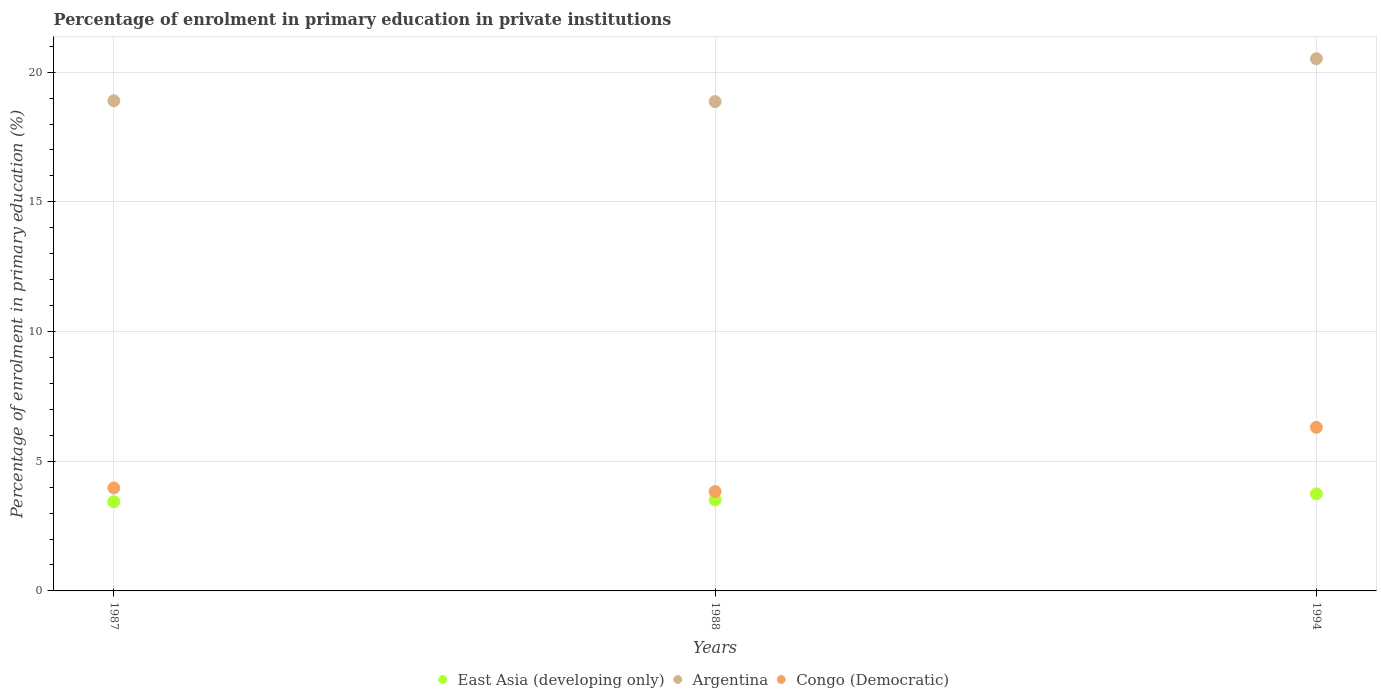How many different coloured dotlines are there?
Give a very brief answer. 3. What is the percentage of enrolment in primary education in Congo (Democratic) in 1988?
Make the answer very short. 3.83. Across all years, what is the maximum percentage of enrolment in primary education in Argentina?
Keep it short and to the point. 20.52. Across all years, what is the minimum percentage of enrolment in primary education in Congo (Democratic)?
Keep it short and to the point. 3.83. What is the total percentage of enrolment in primary education in Argentina in the graph?
Keep it short and to the point. 58.28. What is the difference between the percentage of enrolment in primary education in East Asia (developing only) in 1987 and that in 1988?
Provide a succinct answer. -0.07. What is the difference between the percentage of enrolment in primary education in Argentina in 1988 and the percentage of enrolment in primary education in Congo (Democratic) in 1987?
Your answer should be very brief. 14.89. What is the average percentage of enrolment in primary education in East Asia (developing only) per year?
Make the answer very short. 3.56. In the year 1994, what is the difference between the percentage of enrolment in primary education in Argentina and percentage of enrolment in primary education in East Asia (developing only)?
Offer a terse response. 16.77. What is the ratio of the percentage of enrolment in primary education in Argentina in 1987 to that in 1994?
Ensure brevity in your answer.  0.92. Is the percentage of enrolment in primary education in Argentina in 1988 less than that in 1994?
Your response must be concise. Yes. Is the difference between the percentage of enrolment in primary education in Argentina in 1988 and 1994 greater than the difference between the percentage of enrolment in primary education in East Asia (developing only) in 1988 and 1994?
Provide a short and direct response. No. What is the difference between the highest and the second highest percentage of enrolment in primary education in East Asia (developing only)?
Provide a succinct answer. 0.23. What is the difference between the highest and the lowest percentage of enrolment in primary education in East Asia (developing only)?
Offer a very short reply. 0.3. In how many years, is the percentage of enrolment in primary education in East Asia (developing only) greater than the average percentage of enrolment in primary education in East Asia (developing only) taken over all years?
Make the answer very short. 1. Is the sum of the percentage of enrolment in primary education in East Asia (developing only) in 1987 and 1994 greater than the maximum percentage of enrolment in primary education in Argentina across all years?
Your response must be concise. No. Is the percentage of enrolment in primary education in East Asia (developing only) strictly greater than the percentage of enrolment in primary education in Argentina over the years?
Offer a very short reply. No. Is the percentage of enrolment in primary education in Congo (Democratic) strictly less than the percentage of enrolment in primary education in East Asia (developing only) over the years?
Make the answer very short. No. Does the graph contain any zero values?
Provide a short and direct response. No. Does the graph contain grids?
Your answer should be very brief. Yes. Where does the legend appear in the graph?
Give a very brief answer. Bottom center. How are the legend labels stacked?
Give a very brief answer. Horizontal. What is the title of the graph?
Offer a very short reply. Percentage of enrolment in primary education in private institutions. Does "Latvia" appear as one of the legend labels in the graph?
Your response must be concise. No. What is the label or title of the Y-axis?
Provide a short and direct response. Percentage of enrolment in primary education (%). What is the Percentage of enrolment in primary education (%) in East Asia (developing only) in 1987?
Provide a succinct answer. 3.44. What is the Percentage of enrolment in primary education (%) in Argentina in 1987?
Your answer should be very brief. 18.9. What is the Percentage of enrolment in primary education (%) of Congo (Democratic) in 1987?
Provide a short and direct response. 3.97. What is the Percentage of enrolment in primary education (%) of East Asia (developing only) in 1988?
Provide a short and direct response. 3.51. What is the Percentage of enrolment in primary education (%) of Argentina in 1988?
Keep it short and to the point. 18.86. What is the Percentage of enrolment in primary education (%) of Congo (Democratic) in 1988?
Keep it short and to the point. 3.83. What is the Percentage of enrolment in primary education (%) in East Asia (developing only) in 1994?
Give a very brief answer. 3.74. What is the Percentage of enrolment in primary education (%) of Argentina in 1994?
Ensure brevity in your answer.  20.52. What is the Percentage of enrolment in primary education (%) of Congo (Democratic) in 1994?
Your answer should be compact. 6.31. Across all years, what is the maximum Percentage of enrolment in primary education (%) in East Asia (developing only)?
Provide a short and direct response. 3.74. Across all years, what is the maximum Percentage of enrolment in primary education (%) of Argentina?
Give a very brief answer. 20.52. Across all years, what is the maximum Percentage of enrolment in primary education (%) in Congo (Democratic)?
Your answer should be compact. 6.31. Across all years, what is the minimum Percentage of enrolment in primary education (%) of East Asia (developing only)?
Your response must be concise. 3.44. Across all years, what is the minimum Percentage of enrolment in primary education (%) of Argentina?
Offer a very short reply. 18.86. Across all years, what is the minimum Percentage of enrolment in primary education (%) of Congo (Democratic)?
Offer a terse response. 3.83. What is the total Percentage of enrolment in primary education (%) in East Asia (developing only) in the graph?
Your answer should be very brief. 10.69. What is the total Percentage of enrolment in primary education (%) of Argentina in the graph?
Keep it short and to the point. 58.28. What is the total Percentage of enrolment in primary education (%) of Congo (Democratic) in the graph?
Provide a short and direct response. 14.11. What is the difference between the Percentage of enrolment in primary education (%) of East Asia (developing only) in 1987 and that in 1988?
Provide a short and direct response. -0.07. What is the difference between the Percentage of enrolment in primary education (%) in Argentina in 1987 and that in 1988?
Make the answer very short. 0.03. What is the difference between the Percentage of enrolment in primary education (%) of Congo (Democratic) in 1987 and that in 1988?
Give a very brief answer. 0.14. What is the difference between the Percentage of enrolment in primary education (%) of East Asia (developing only) in 1987 and that in 1994?
Keep it short and to the point. -0.3. What is the difference between the Percentage of enrolment in primary education (%) in Argentina in 1987 and that in 1994?
Make the answer very short. -1.62. What is the difference between the Percentage of enrolment in primary education (%) of Congo (Democratic) in 1987 and that in 1994?
Your answer should be very brief. -2.34. What is the difference between the Percentage of enrolment in primary education (%) of East Asia (developing only) in 1988 and that in 1994?
Offer a terse response. -0.23. What is the difference between the Percentage of enrolment in primary education (%) in Argentina in 1988 and that in 1994?
Make the answer very short. -1.65. What is the difference between the Percentage of enrolment in primary education (%) in Congo (Democratic) in 1988 and that in 1994?
Offer a very short reply. -2.47. What is the difference between the Percentage of enrolment in primary education (%) of East Asia (developing only) in 1987 and the Percentage of enrolment in primary education (%) of Argentina in 1988?
Keep it short and to the point. -15.42. What is the difference between the Percentage of enrolment in primary education (%) of East Asia (developing only) in 1987 and the Percentage of enrolment in primary education (%) of Congo (Democratic) in 1988?
Your response must be concise. -0.39. What is the difference between the Percentage of enrolment in primary education (%) in Argentina in 1987 and the Percentage of enrolment in primary education (%) in Congo (Democratic) in 1988?
Ensure brevity in your answer.  15.06. What is the difference between the Percentage of enrolment in primary education (%) of East Asia (developing only) in 1987 and the Percentage of enrolment in primary education (%) of Argentina in 1994?
Provide a short and direct response. -17.08. What is the difference between the Percentage of enrolment in primary education (%) in East Asia (developing only) in 1987 and the Percentage of enrolment in primary education (%) in Congo (Democratic) in 1994?
Offer a very short reply. -2.87. What is the difference between the Percentage of enrolment in primary education (%) in Argentina in 1987 and the Percentage of enrolment in primary education (%) in Congo (Democratic) in 1994?
Offer a very short reply. 12.59. What is the difference between the Percentage of enrolment in primary education (%) of East Asia (developing only) in 1988 and the Percentage of enrolment in primary education (%) of Argentina in 1994?
Give a very brief answer. -17.01. What is the difference between the Percentage of enrolment in primary education (%) in East Asia (developing only) in 1988 and the Percentage of enrolment in primary education (%) in Congo (Democratic) in 1994?
Your answer should be very brief. -2.8. What is the difference between the Percentage of enrolment in primary education (%) in Argentina in 1988 and the Percentage of enrolment in primary education (%) in Congo (Democratic) in 1994?
Provide a succinct answer. 12.56. What is the average Percentage of enrolment in primary education (%) of East Asia (developing only) per year?
Offer a terse response. 3.56. What is the average Percentage of enrolment in primary education (%) in Argentina per year?
Offer a very short reply. 19.43. What is the average Percentage of enrolment in primary education (%) in Congo (Democratic) per year?
Provide a short and direct response. 4.7. In the year 1987, what is the difference between the Percentage of enrolment in primary education (%) of East Asia (developing only) and Percentage of enrolment in primary education (%) of Argentina?
Offer a terse response. -15.46. In the year 1987, what is the difference between the Percentage of enrolment in primary education (%) in East Asia (developing only) and Percentage of enrolment in primary education (%) in Congo (Democratic)?
Keep it short and to the point. -0.53. In the year 1987, what is the difference between the Percentage of enrolment in primary education (%) of Argentina and Percentage of enrolment in primary education (%) of Congo (Democratic)?
Provide a short and direct response. 14.93. In the year 1988, what is the difference between the Percentage of enrolment in primary education (%) in East Asia (developing only) and Percentage of enrolment in primary education (%) in Argentina?
Your answer should be very brief. -15.36. In the year 1988, what is the difference between the Percentage of enrolment in primary education (%) in East Asia (developing only) and Percentage of enrolment in primary education (%) in Congo (Democratic)?
Keep it short and to the point. -0.32. In the year 1988, what is the difference between the Percentage of enrolment in primary education (%) in Argentina and Percentage of enrolment in primary education (%) in Congo (Democratic)?
Your answer should be very brief. 15.03. In the year 1994, what is the difference between the Percentage of enrolment in primary education (%) in East Asia (developing only) and Percentage of enrolment in primary education (%) in Argentina?
Give a very brief answer. -16.77. In the year 1994, what is the difference between the Percentage of enrolment in primary education (%) in East Asia (developing only) and Percentage of enrolment in primary education (%) in Congo (Democratic)?
Provide a succinct answer. -2.56. In the year 1994, what is the difference between the Percentage of enrolment in primary education (%) in Argentina and Percentage of enrolment in primary education (%) in Congo (Democratic)?
Your response must be concise. 14.21. What is the ratio of the Percentage of enrolment in primary education (%) of East Asia (developing only) in 1987 to that in 1988?
Provide a short and direct response. 0.98. What is the ratio of the Percentage of enrolment in primary education (%) of Argentina in 1987 to that in 1988?
Your answer should be compact. 1. What is the ratio of the Percentage of enrolment in primary education (%) of Congo (Democratic) in 1987 to that in 1988?
Give a very brief answer. 1.04. What is the ratio of the Percentage of enrolment in primary education (%) in East Asia (developing only) in 1987 to that in 1994?
Offer a terse response. 0.92. What is the ratio of the Percentage of enrolment in primary education (%) in Argentina in 1987 to that in 1994?
Offer a very short reply. 0.92. What is the ratio of the Percentage of enrolment in primary education (%) of Congo (Democratic) in 1987 to that in 1994?
Make the answer very short. 0.63. What is the ratio of the Percentage of enrolment in primary education (%) of East Asia (developing only) in 1988 to that in 1994?
Provide a succinct answer. 0.94. What is the ratio of the Percentage of enrolment in primary education (%) of Argentina in 1988 to that in 1994?
Provide a short and direct response. 0.92. What is the ratio of the Percentage of enrolment in primary education (%) of Congo (Democratic) in 1988 to that in 1994?
Offer a terse response. 0.61. What is the difference between the highest and the second highest Percentage of enrolment in primary education (%) of East Asia (developing only)?
Offer a very short reply. 0.23. What is the difference between the highest and the second highest Percentage of enrolment in primary education (%) of Argentina?
Give a very brief answer. 1.62. What is the difference between the highest and the second highest Percentage of enrolment in primary education (%) in Congo (Democratic)?
Keep it short and to the point. 2.34. What is the difference between the highest and the lowest Percentage of enrolment in primary education (%) of East Asia (developing only)?
Offer a very short reply. 0.3. What is the difference between the highest and the lowest Percentage of enrolment in primary education (%) of Argentina?
Give a very brief answer. 1.65. What is the difference between the highest and the lowest Percentage of enrolment in primary education (%) in Congo (Democratic)?
Provide a succinct answer. 2.47. 